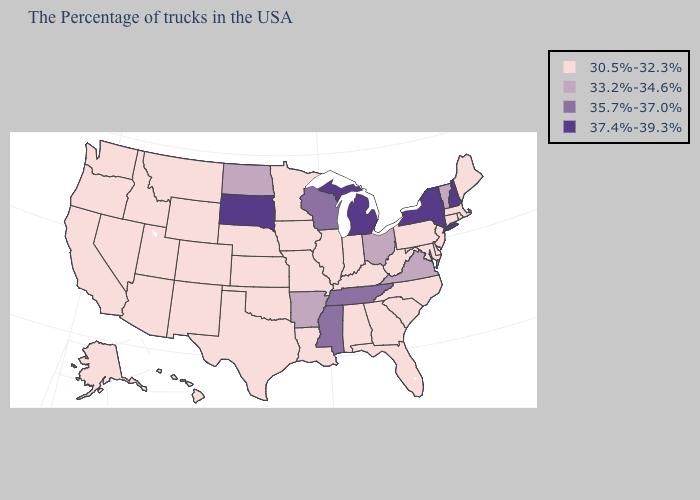Does Georgia have a lower value than North Carolina?
Give a very brief answer. No. What is the highest value in states that border Ohio?
Short answer required. 37.4%-39.3%. What is the value of Tennessee?
Concise answer only. 35.7%-37.0%. Name the states that have a value in the range 30.5%-32.3%?
Quick response, please. Maine, Massachusetts, Rhode Island, Connecticut, New Jersey, Delaware, Maryland, Pennsylvania, North Carolina, South Carolina, West Virginia, Florida, Georgia, Kentucky, Indiana, Alabama, Illinois, Louisiana, Missouri, Minnesota, Iowa, Kansas, Nebraska, Oklahoma, Texas, Wyoming, Colorado, New Mexico, Utah, Montana, Arizona, Idaho, Nevada, California, Washington, Oregon, Alaska, Hawaii. Does New Hampshire have the same value as South Dakota?
Keep it brief. Yes. Does Arkansas have the highest value in the USA?
Short answer required. No. What is the value of Ohio?
Quick response, please. 33.2%-34.6%. What is the value of Mississippi?
Give a very brief answer. 35.7%-37.0%. Name the states that have a value in the range 33.2%-34.6%?
Keep it brief. Vermont, Virginia, Ohio, Arkansas, North Dakota. Does Kansas have the highest value in the MidWest?
Concise answer only. No. Which states have the lowest value in the MidWest?
Quick response, please. Indiana, Illinois, Missouri, Minnesota, Iowa, Kansas, Nebraska. What is the highest value in states that border Alabama?
Be succinct. 35.7%-37.0%. Name the states that have a value in the range 30.5%-32.3%?
Answer briefly. Maine, Massachusetts, Rhode Island, Connecticut, New Jersey, Delaware, Maryland, Pennsylvania, North Carolina, South Carolina, West Virginia, Florida, Georgia, Kentucky, Indiana, Alabama, Illinois, Louisiana, Missouri, Minnesota, Iowa, Kansas, Nebraska, Oklahoma, Texas, Wyoming, Colorado, New Mexico, Utah, Montana, Arizona, Idaho, Nevada, California, Washington, Oregon, Alaska, Hawaii. Name the states that have a value in the range 30.5%-32.3%?
Be succinct. Maine, Massachusetts, Rhode Island, Connecticut, New Jersey, Delaware, Maryland, Pennsylvania, North Carolina, South Carolina, West Virginia, Florida, Georgia, Kentucky, Indiana, Alabama, Illinois, Louisiana, Missouri, Minnesota, Iowa, Kansas, Nebraska, Oklahoma, Texas, Wyoming, Colorado, New Mexico, Utah, Montana, Arizona, Idaho, Nevada, California, Washington, Oregon, Alaska, Hawaii. What is the value of Mississippi?
Concise answer only. 35.7%-37.0%. 